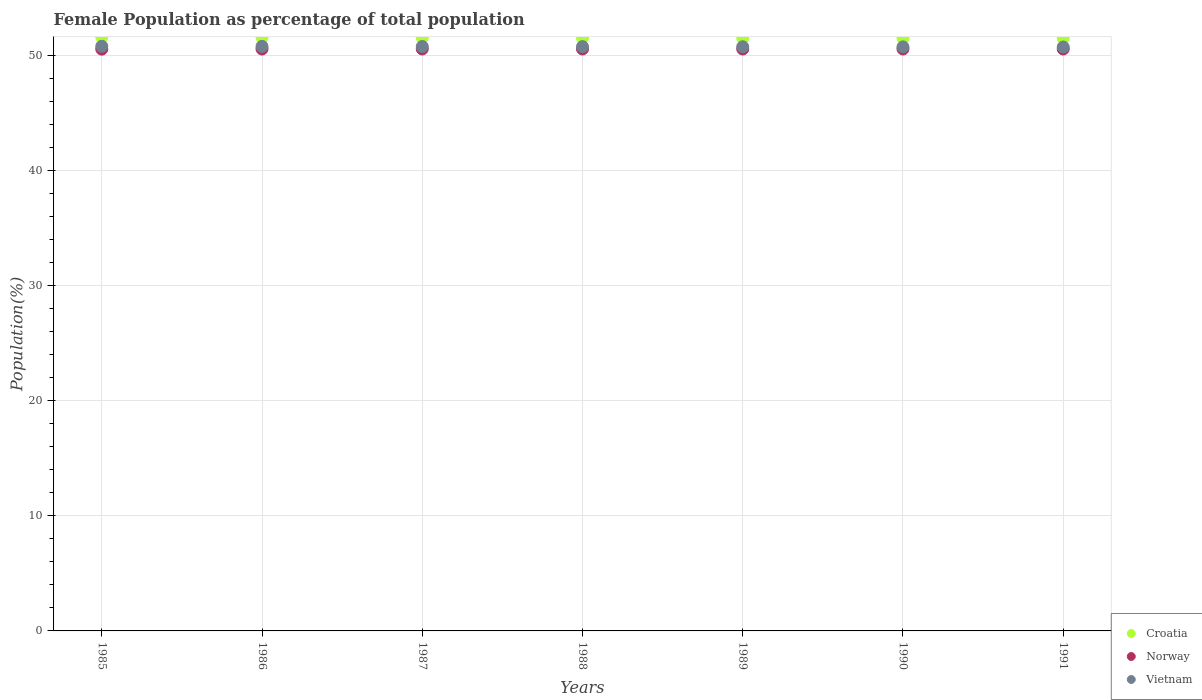How many different coloured dotlines are there?
Your response must be concise. 3. What is the female population in in Norway in 1991?
Give a very brief answer. 50.58. Across all years, what is the maximum female population in in Croatia?
Ensure brevity in your answer.  51.61. Across all years, what is the minimum female population in in Norway?
Keep it short and to the point. 50.57. In which year was the female population in in Norway maximum?
Keep it short and to the point. 1987. What is the total female population in in Vietnam in the graph?
Your response must be concise. 355.49. What is the difference between the female population in in Croatia in 1985 and that in 1991?
Make the answer very short. 0.09. What is the difference between the female population in in Vietnam in 1985 and the female population in in Croatia in 1990?
Provide a short and direct response. -0.7. What is the average female population in in Croatia per year?
Provide a short and direct response. 51.55. In the year 1989, what is the difference between the female population in in Vietnam and female population in in Croatia?
Offer a terse response. -0.75. What is the ratio of the female population in in Vietnam in 1988 to that in 1989?
Ensure brevity in your answer.  1. Is the female population in in Croatia in 1987 less than that in 1991?
Ensure brevity in your answer.  No. Is the difference between the female population in in Vietnam in 1986 and 1988 greater than the difference between the female population in in Croatia in 1986 and 1988?
Give a very brief answer. No. What is the difference between the highest and the second highest female population in in Norway?
Provide a short and direct response. 0. What is the difference between the highest and the lowest female population in in Vietnam?
Offer a very short reply. 0.06. In how many years, is the female population in in Vietnam greater than the average female population in in Vietnam taken over all years?
Keep it short and to the point. 3. Is the sum of the female population in in Norway in 1985 and 1987 greater than the maximum female population in in Croatia across all years?
Offer a terse response. Yes. Is it the case that in every year, the sum of the female population in in Croatia and female population in in Norway  is greater than the female population in in Vietnam?
Keep it short and to the point. Yes. What is the difference between two consecutive major ticks on the Y-axis?
Keep it short and to the point. 10. What is the title of the graph?
Make the answer very short. Female Population as percentage of total population. Does "Grenada" appear as one of the legend labels in the graph?
Keep it short and to the point. No. What is the label or title of the X-axis?
Your answer should be very brief. Years. What is the label or title of the Y-axis?
Give a very brief answer. Population(%). What is the Population(%) of Croatia in 1985?
Make the answer very short. 51.61. What is the Population(%) of Norway in 1985?
Give a very brief answer. 50.57. What is the Population(%) in Vietnam in 1985?
Provide a succinct answer. 50.82. What is the Population(%) in Croatia in 1986?
Offer a terse response. 51.59. What is the Population(%) in Norway in 1986?
Offer a very short reply. 50.58. What is the Population(%) of Vietnam in 1986?
Provide a succinct answer. 50.8. What is the Population(%) in Croatia in 1987?
Your response must be concise. 51.57. What is the Population(%) of Norway in 1987?
Offer a terse response. 50.58. What is the Population(%) of Vietnam in 1987?
Offer a very short reply. 50.79. What is the Population(%) of Croatia in 1988?
Offer a terse response. 51.54. What is the Population(%) of Norway in 1988?
Give a very brief answer. 50.58. What is the Population(%) of Vietnam in 1988?
Your answer should be compact. 50.78. What is the Population(%) of Croatia in 1989?
Provide a succinct answer. 51.52. What is the Population(%) in Norway in 1989?
Your answer should be compact. 50.58. What is the Population(%) of Vietnam in 1989?
Offer a very short reply. 50.77. What is the Population(%) of Croatia in 1990?
Your answer should be very brief. 51.52. What is the Population(%) of Norway in 1990?
Offer a very short reply. 50.58. What is the Population(%) in Vietnam in 1990?
Offer a very short reply. 50.76. What is the Population(%) of Croatia in 1991?
Ensure brevity in your answer.  51.52. What is the Population(%) in Norway in 1991?
Your response must be concise. 50.58. What is the Population(%) of Vietnam in 1991?
Keep it short and to the point. 50.75. Across all years, what is the maximum Population(%) in Croatia?
Your answer should be compact. 51.61. Across all years, what is the maximum Population(%) in Norway?
Your answer should be compact. 50.58. Across all years, what is the maximum Population(%) of Vietnam?
Give a very brief answer. 50.82. Across all years, what is the minimum Population(%) of Croatia?
Your answer should be very brief. 51.52. Across all years, what is the minimum Population(%) of Norway?
Your answer should be compact. 50.57. Across all years, what is the minimum Population(%) of Vietnam?
Provide a succinct answer. 50.75. What is the total Population(%) in Croatia in the graph?
Provide a short and direct response. 360.87. What is the total Population(%) of Norway in the graph?
Provide a short and direct response. 354.03. What is the total Population(%) in Vietnam in the graph?
Your response must be concise. 355.49. What is the difference between the Population(%) in Croatia in 1985 and that in 1986?
Ensure brevity in your answer.  0.01. What is the difference between the Population(%) of Norway in 1985 and that in 1986?
Your answer should be compact. -0.01. What is the difference between the Population(%) of Vietnam in 1985 and that in 1986?
Offer a terse response. 0.01. What is the difference between the Population(%) in Croatia in 1985 and that in 1987?
Provide a succinct answer. 0.04. What is the difference between the Population(%) in Norway in 1985 and that in 1987?
Provide a succinct answer. -0.01. What is the difference between the Population(%) of Vietnam in 1985 and that in 1987?
Give a very brief answer. 0.02. What is the difference between the Population(%) in Croatia in 1985 and that in 1988?
Make the answer very short. 0.06. What is the difference between the Population(%) in Norway in 1985 and that in 1988?
Give a very brief answer. -0.01. What is the difference between the Population(%) of Vietnam in 1985 and that in 1988?
Keep it short and to the point. 0.03. What is the difference between the Population(%) in Croatia in 1985 and that in 1989?
Keep it short and to the point. 0.08. What is the difference between the Population(%) of Norway in 1985 and that in 1989?
Keep it short and to the point. -0.01. What is the difference between the Population(%) in Vietnam in 1985 and that in 1989?
Offer a very short reply. 0.04. What is the difference between the Population(%) of Croatia in 1985 and that in 1990?
Provide a succinct answer. 0.09. What is the difference between the Population(%) of Norway in 1985 and that in 1990?
Give a very brief answer. -0.01. What is the difference between the Population(%) of Vietnam in 1985 and that in 1990?
Offer a terse response. 0.05. What is the difference between the Population(%) of Croatia in 1985 and that in 1991?
Provide a succinct answer. 0.09. What is the difference between the Population(%) in Norway in 1985 and that in 1991?
Your answer should be very brief. -0.01. What is the difference between the Population(%) of Vietnam in 1985 and that in 1991?
Your answer should be very brief. 0.06. What is the difference between the Population(%) in Croatia in 1986 and that in 1987?
Provide a succinct answer. 0.02. What is the difference between the Population(%) in Norway in 1986 and that in 1987?
Make the answer very short. -0. What is the difference between the Population(%) in Vietnam in 1986 and that in 1987?
Keep it short and to the point. 0.01. What is the difference between the Population(%) of Croatia in 1986 and that in 1988?
Ensure brevity in your answer.  0.05. What is the difference between the Population(%) of Norway in 1986 and that in 1988?
Offer a terse response. -0. What is the difference between the Population(%) of Vietnam in 1986 and that in 1988?
Ensure brevity in your answer.  0.02. What is the difference between the Population(%) in Croatia in 1986 and that in 1989?
Offer a terse response. 0.07. What is the difference between the Population(%) of Norway in 1986 and that in 1989?
Provide a short and direct response. -0. What is the difference between the Population(%) of Vietnam in 1986 and that in 1989?
Keep it short and to the point. 0.03. What is the difference between the Population(%) in Croatia in 1986 and that in 1990?
Give a very brief answer. 0.08. What is the difference between the Population(%) in Norway in 1986 and that in 1990?
Your response must be concise. -0. What is the difference between the Population(%) in Vietnam in 1986 and that in 1990?
Ensure brevity in your answer.  0.04. What is the difference between the Population(%) in Croatia in 1986 and that in 1991?
Offer a terse response. 0.07. What is the difference between the Population(%) of Norway in 1986 and that in 1991?
Offer a very short reply. -0. What is the difference between the Population(%) of Vietnam in 1986 and that in 1991?
Give a very brief answer. 0.05. What is the difference between the Population(%) in Croatia in 1987 and that in 1988?
Your answer should be very brief. 0.03. What is the difference between the Population(%) of Norway in 1987 and that in 1988?
Make the answer very short. 0. What is the difference between the Population(%) in Vietnam in 1987 and that in 1988?
Give a very brief answer. 0.01. What is the difference between the Population(%) in Croatia in 1987 and that in 1989?
Provide a short and direct response. 0.05. What is the difference between the Population(%) of Norway in 1987 and that in 1989?
Your response must be concise. 0. What is the difference between the Population(%) in Vietnam in 1987 and that in 1989?
Ensure brevity in your answer.  0.02. What is the difference between the Population(%) of Croatia in 1987 and that in 1990?
Provide a short and direct response. 0.05. What is the difference between the Population(%) in Norway in 1987 and that in 1990?
Your response must be concise. 0. What is the difference between the Population(%) in Vietnam in 1987 and that in 1990?
Provide a succinct answer. 0.03. What is the difference between the Population(%) of Croatia in 1987 and that in 1991?
Your answer should be very brief. 0.05. What is the difference between the Population(%) of Norway in 1987 and that in 1991?
Make the answer very short. 0. What is the difference between the Population(%) of Vietnam in 1987 and that in 1991?
Provide a succinct answer. 0.04. What is the difference between the Population(%) in Croatia in 1988 and that in 1989?
Make the answer very short. 0.02. What is the difference between the Population(%) in Norway in 1988 and that in 1989?
Make the answer very short. 0. What is the difference between the Population(%) of Vietnam in 1988 and that in 1989?
Provide a succinct answer. 0.01. What is the difference between the Population(%) in Croatia in 1988 and that in 1990?
Your answer should be compact. 0.03. What is the difference between the Population(%) in Norway in 1988 and that in 1990?
Give a very brief answer. 0. What is the difference between the Population(%) in Vietnam in 1988 and that in 1990?
Your response must be concise. 0.02. What is the difference between the Population(%) in Croatia in 1988 and that in 1991?
Ensure brevity in your answer.  0.03. What is the difference between the Population(%) of Norway in 1988 and that in 1991?
Offer a very short reply. 0. What is the difference between the Population(%) of Vietnam in 1988 and that in 1991?
Keep it short and to the point. 0.03. What is the difference between the Population(%) in Croatia in 1989 and that in 1990?
Give a very brief answer. 0.01. What is the difference between the Population(%) of Norway in 1989 and that in 1990?
Your answer should be compact. 0. What is the difference between the Population(%) in Vietnam in 1989 and that in 1990?
Your answer should be very brief. 0.01. What is the difference between the Population(%) of Croatia in 1989 and that in 1991?
Offer a very short reply. 0.01. What is the difference between the Population(%) in Norway in 1989 and that in 1991?
Offer a very short reply. -0. What is the difference between the Population(%) in Vietnam in 1989 and that in 1991?
Ensure brevity in your answer.  0.02. What is the difference between the Population(%) of Croatia in 1990 and that in 1991?
Ensure brevity in your answer.  -0. What is the difference between the Population(%) of Norway in 1990 and that in 1991?
Offer a terse response. -0. What is the difference between the Population(%) of Vietnam in 1990 and that in 1991?
Provide a succinct answer. 0.01. What is the difference between the Population(%) of Croatia in 1985 and the Population(%) of Norway in 1986?
Provide a succinct answer. 1.03. What is the difference between the Population(%) of Croatia in 1985 and the Population(%) of Vietnam in 1986?
Keep it short and to the point. 0.8. What is the difference between the Population(%) in Norway in 1985 and the Population(%) in Vietnam in 1986?
Provide a succinct answer. -0.24. What is the difference between the Population(%) of Croatia in 1985 and the Population(%) of Norway in 1987?
Offer a very short reply. 1.03. What is the difference between the Population(%) of Croatia in 1985 and the Population(%) of Vietnam in 1987?
Your answer should be very brief. 0.81. What is the difference between the Population(%) of Norway in 1985 and the Population(%) of Vietnam in 1987?
Make the answer very short. -0.23. What is the difference between the Population(%) of Croatia in 1985 and the Population(%) of Norway in 1988?
Keep it short and to the point. 1.03. What is the difference between the Population(%) in Croatia in 1985 and the Population(%) in Vietnam in 1988?
Your answer should be compact. 0.82. What is the difference between the Population(%) in Norway in 1985 and the Population(%) in Vietnam in 1988?
Provide a succinct answer. -0.22. What is the difference between the Population(%) in Croatia in 1985 and the Population(%) in Norway in 1989?
Your response must be concise. 1.03. What is the difference between the Population(%) of Croatia in 1985 and the Population(%) of Vietnam in 1989?
Your answer should be compact. 0.83. What is the difference between the Population(%) of Norway in 1985 and the Population(%) of Vietnam in 1989?
Make the answer very short. -0.21. What is the difference between the Population(%) in Croatia in 1985 and the Population(%) in Norway in 1990?
Offer a very short reply. 1.03. What is the difference between the Population(%) in Croatia in 1985 and the Population(%) in Vietnam in 1990?
Offer a terse response. 0.84. What is the difference between the Population(%) in Norway in 1985 and the Population(%) in Vietnam in 1990?
Make the answer very short. -0.2. What is the difference between the Population(%) in Croatia in 1985 and the Population(%) in Norway in 1991?
Your response must be concise. 1.03. What is the difference between the Population(%) of Croatia in 1985 and the Population(%) of Vietnam in 1991?
Provide a succinct answer. 0.85. What is the difference between the Population(%) of Norway in 1985 and the Population(%) of Vietnam in 1991?
Provide a succinct answer. -0.19. What is the difference between the Population(%) of Croatia in 1986 and the Population(%) of Norway in 1987?
Offer a very short reply. 1.01. What is the difference between the Population(%) in Croatia in 1986 and the Population(%) in Vietnam in 1987?
Make the answer very short. 0.8. What is the difference between the Population(%) of Norway in 1986 and the Population(%) of Vietnam in 1987?
Give a very brief answer. -0.22. What is the difference between the Population(%) in Croatia in 1986 and the Population(%) in Norway in 1988?
Ensure brevity in your answer.  1.01. What is the difference between the Population(%) of Croatia in 1986 and the Population(%) of Vietnam in 1988?
Offer a very short reply. 0.81. What is the difference between the Population(%) of Norway in 1986 and the Population(%) of Vietnam in 1988?
Your answer should be very brief. -0.21. What is the difference between the Population(%) of Croatia in 1986 and the Population(%) of Norway in 1989?
Offer a very short reply. 1.01. What is the difference between the Population(%) in Croatia in 1986 and the Population(%) in Vietnam in 1989?
Make the answer very short. 0.82. What is the difference between the Population(%) in Norway in 1986 and the Population(%) in Vietnam in 1989?
Your response must be concise. -0.2. What is the difference between the Population(%) of Croatia in 1986 and the Population(%) of Norway in 1990?
Make the answer very short. 1.02. What is the difference between the Population(%) of Croatia in 1986 and the Population(%) of Vietnam in 1990?
Keep it short and to the point. 0.83. What is the difference between the Population(%) in Norway in 1986 and the Population(%) in Vietnam in 1990?
Your response must be concise. -0.19. What is the difference between the Population(%) of Croatia in 1986 and the Population(%) of Norway in 1991?
Give a very brief answer. 1.01. What is the difference between the Population(%) in Croatia in 1986 and the Population(%) in Vietnam in 1991?
Offer a terse response. 0.84. What is the difference between the Population(%) of Norway in 1986 and the Population(%) of Vietnam in 1991?
Provide a short and direct response. -0.18. What is the difference between the Population(%) of Croatia in 1987 and the Population(%) of Norway in 1988?
Offer a very short reply. 0.99. What is the difference between the Population(%) of Croatia in 1987 and the Population(%) of Vietnam in 1988?
Your answer should be very brief. 0.79. What is the difference between the Population(%) in Norway in 1987 and the Population(%) in Vietnam in 1988?
Offer a terse response. -0.2. What is the difference between the Population(%) in Croatia in 1987 and the Population(%) in Norway in 1989?
Your answer should be very brief. 0.99. What is the difference between the Population(%) of Croatia in 1987 and the Population(%) of Vietnam in 1989?
Keep it short and to the point. 0.8. What is the difference between the Population(%) of Norway in 1987 and the Population(%) of Vietnam in 1989?
Ensure brevity in your answer.  -0.19. What is the difference between the Population(%) of Croatia in 1987 and the Population(%) of Vietnam in 1990?
Provide a short and direct response. 0.81. What is the difference between the Population(%) of Norway in 1987 and the Population(%) of Vietnam in 1990?
Keep it short and to the point. -0.18. What is the difference between the Population(%) of Croatia in 1987 and the Population(%) of Norway in 1991?
Ensure brevity in your answer.  0.99. What is the difference between the Population(%) of Croatia in 1987 and the Population(%) of Vietnam in 1991?
Your answer should be compact. 0.82. What is the difference between the Population(%) in Norway in 1987 and the Population(%) in Vietnam in 1991?
Provide a short and direct response. -0.17. What is the difference between the Population(%) in Croatia in 1988 and the Population(%) in Norway in 1989?
Keep it short and to the point. 0.97. What is the difference between the Population(%) in Croatia in 1988 and the Population(%) in Vietnam in 1989?
Offer a very short reply. 0.77. What is the difference between the Population(%) in Norway in 1988 and the Population(%) in Vietnam in 1989?
Ensure brevity in your answer.  -0.19. What is the difference between the Population(%) of Croatia in 1988 and the Population(%) of Norway in 1990?
Your response must be concise. 0.97. What is the difference between the Population(%) in Croatia in 1988 and the Population(%) in Vietnam in 1990?
Give a very brief answer. 0.78. What is the difference between the Population(%) in Norway in 1988 and the Population(%) in Vietnam in 1990?
Make the answer very short. -0.18. What is the difference between the Population(%) of Croatia in 1988 and the Population(%) of Norway in 1991?
Provide a short and direct response. 0.97. What is the difference between the Population(%) of Croatia in 1988 and the Population(%) of Vietnam in 1991?
Offer a very short reply. 0.79. What is the difference between the Population(%) of Norway in 1988 and the Population(%) of Vietnam in 1991?
Keep it short and to the point. -0.17. What is the difference between the Population(%) in Croatia in 1989 and the Population(%) in Norway in 1990?
Your response must be concise. 0.95. What is the difference between the Population(%) of Croatia in 1989 and the Population(%) of Vietnam in 1990?
Offer a very short reply. 0.76. What is the difference between the Population(%) of Norway in 1989 and the Population(%) of Vietnam in 1990?
Your answer should be very brief. -0.19. What is the difference between the Population(%) of Croatia in 1989 and the Population(%) of Norway in 1991?
Provide a short and direct response. 0.95. What is the difference between the Population(%) in Croatia in 1989 and the Population(%) in Vietnam in 1991?
Give a very brief answer. 0.77. What is the difference between the Population(%) in Norway in 1989 and the Population(%) in Vietnam in 1991?
Provide a short and direct response. -0.18. What is the difference between the Population(%) in Croatia in 1990 and the Population(%) in Vietnam in 1991?
Your answer should be very brief. 0.76. What is the difference between the Population(%) in Norway in 1990 and the Population(%) in Vietnam in 1991?
Give a very brief answer. -0.18. What is the average Population(%) in Croatia per year?
Ensure brevity in your answer.  51.55. What is the average Population(%) in Norway per year?
Your answer should be very brief. 50.58. What is the average Population(%) of Vietnam per year?
Your response must be concise. 50.78. In the year 1985, what is the difference between the Population(%) in Croatia and Population(%) in Norway?
Ensure brevity in your answer.  1.04. In the year 1985, what is the difference between the Population(%) of Croatia and Population(%) of Vietnam?
Offer a terse response. 0.79. In the year 1985, what is the difference between the Population(%) in Norway and Population(%) in Vietnam?
Offer a terse response. -0.25. In the year 1986, what is the difference between the Population(%) of Croatia and Population(%) of Norway?
Provide a short and direct response. 1.02. In the year 1986, what is the difference between the Population(%) of Croatia and Population(%) of Vietnam?
Provide a succinct answer. 0.79. In the year 1986, what is the difference between the Population(%) of Norway and Population(%) of Vietnam?
Your answer should be compact. -0.23. In the year 1987, what is the difference between the Population(%) of Croatia and Population(%) of Norway?
Keep it short and to the point. 0.99. In the year 1987, what is the difference between the Population(%) of Croatia and Population(%) of Vietnam?
Offer a terse response. 0.78. In the year 1987, what is the difference between the Population(%) of Norway and Population(%) of Vietnam?
Offer a terse response. -0.21. In the year 1988, what is the difference between the Population(%) of Croatia and Population(%) of Norway?
Offer a terse response. 0.97. In the year 1988, what is the difference between the Population(%) in Croatia and Population(%) in Vietnam?
Offer a very short reply. 0.76. In the year 1988, what is the difference between the Population(%) of Norway and Population(%) of Vietnam?
Keep it short and to the point. -0.2. In the year 1989, what is the difference between the Population(%) of Croatia and Population(%) of Norway?
Your answer should be compact. 0.95. In the year 1989, what is the difference between the Population(%) in Croatia and Population(%) in Vietnam?
Your answer should be compact. 0.75. In the year 1989, what is the difference between the Population(%) in Norway and Population(%) in Vietnam?
Offer a very short reply. -0.2. In the year 1990, what is the difference between the Population(%) of Croatia and Population(%) of Norway?
Offer a terse response. 0.94. In the year 1990, what is the difference between the Population(%) in Croatia and Population(%) in Vietnam?
Provide a short and direct response. 0.75. In the year 1990, what is the difference between the Population(%) of Norway and Population(%) of Vietnam?
Your response must be concise. -0.19. In the year 1991, what is the difference between the Population(%) in Croatia and Population(%) in Norway?
Your response must be concise. 0.94. In the year 1991, what is the difference between the Population(%) in Croatia and Population(%) in Vietnam?
Your response must be concise. 0.77. In the year 1991, what is the difference between the Population(%) in Norway and Population(%) in Vietnam?
Your answer should be very brief. -0.18. What is the ratio of the Population(%) in Croatia in 1985 to that in 1986?
Provide a short and direct response. 1. What is the ratio of the Population(%) in Norway in 1985 to that in 1986?
Your answer should be very brief. 1. What is the ratio of the Population(%) in Vietnam in 1985 to that in 1986?
Offer a very short reply. 1. What is the ratio of the Population(%) of Croatia in 1985 to that in 1987?
Your answer should be very brief. 1. What is the ratio of the Population(%) of Vietnam in 1985 to that in 1987?
Give a very brief answer. 1. What is the ratio of the Population(%) in Croatia in 1985 to that in 1988?
Keep it short and to the point. 1. What is the ratio of the Population(%) in Vietnam in 1985 to that in 1988?
Your answer should be very brief. 1. What is the ratio of the Population(%) of Croatia in 1985 to that in 1989?
Your response must be concise. 1. What is the ratio of the Population(%) of Vietnam in 1985 to that in 1989?
Your response must be concise. 1. What is the ratio of the Population(%) of Croatia in 1985 to that in 1990?
Your answer should be very brief. 1. What is the ratio of the Population(%) in Norway in 1985 to that in 1990?
Offer a terse response. 1. What is the ratio of the Population(%) of Croatia in 1985 to that in 1991?
Make the answer very short. 1. What is the ratio of the Population(%) in Norway in 1985 to that in 1991?
Provide a short and direct response. 1. What is the ratio of the Population(%) in Vietnam in 1985 to that in 1991?
Make the answer very short. 1. What is the ratio of the Population(%) in Croatia in 1986 to that in 1987?
Offer a terse response. 1. What is the ratio of the Population(%) of Vietnam in 1986 to that in 1987?
Offer a terse response. 1. What is the ratio of the Population(%) in Croatia in 1986 to that in 1988?
Offer a terse response. 1. What is the ratio of the Population(%) of Vietnam in 1986 to that in 1988?
Offer a terse response. 1. What is the ratio of the Population(%) in Norway in 1986 to that in 1989?
Make the answer very short. 1. What is the ratio of the Population(%) in Vietnam in 1986 to that in 1989?
Make the answer very short. 1. What is the ratio of the Population(%) of Croatia in 1986 to that in 1990?
Give a very brief answer. 1. What is the ratio of the Population(%) of Croatia in 1986 to that in 1991?
Your response must be concise. 1. What is the ratio of the Population(%) in Norway in 1986 to that in 1991?
Your answer should be compact. 1. What is the ratio of the Population(%) in Croatia in 1987 to that in 1989?
Your answer should be very brief. 1. What is the ratio of the Population(%) of Vietnam in 1987 to that in 1989?
Offer a terse response. 1. What is the ratio of the Population(%) in Croatia in 1987 to that in 1990?
Offer a very short reply. 1. What is the ratio of the Population(%) of Norway in 1987 to that in 1990?
Provide a succinct answer. 1. What is the ratio of the Population(%) of Vietnam in 1987 to that in 1991?
Make the answer very short. 1. What is the ratio of the Population(%) of Croatia in 1988 to that in 1989?
Keep it short and to the point. 1. What is the ratio of the Population(%) in Croatia in 1988 to that in 1990?
Provide a short and direct response. 1. What is the ratio of the Population(%) of Norway in 1988 to that in 1991?
Offer a terse response. 1. What is the ratio of the Population(%) in Vietnam in 1988 to that in 1991?
Make the answer very short. 1. What is the ratio of the Population(%) in Vietnam in 1989 to that in 1990?
Provide a succinct answer. 1. What is the ratio of the Population(%) in Vietnam in 1989 to that in 1991?
Your answer should be very brief. 1. What is the ratio of the Population(%) in Croatia in 1990 to that in 1991?
Provide a short and direct response. 1. What is the ratio of the Population(%) in Norway in 1990 to that in 1991?
Keep it short and to the point. 1. What is the difference between the highest and the second highest Population(%) in Croatia?
Keep it short and to the point. 0.01. What is the difference between the highest and the second highest Population(%) of Vietnam?
Provide a succinct answer. 0.01. What is the difference between the highest and the lowest Population(%) in Croatia?
Provide a short and direct response. 0.09. What is the difference between the highest and the lowest Population(%) of Norway?
Make the answer very short. 0.01. What is the difference between the highest and the lowest Population(%) in Vietnam?
Your answer should be compact. 0.06. 